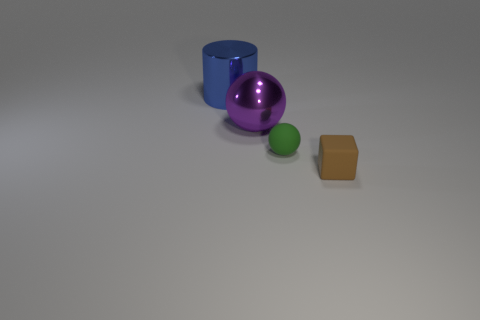What number of purple objects are small shiny spheres or large metal cylinders?
Offer a very short reply. 0. There is a object that is to the right of the purple ball and on the left side of the brown thing; how big is it?
Keep it short and to the point. Small. Are there more rubber cubes to the left of the tiny brown object than tiny rubber balls?
Your answer should be very brief. No. How many balls are either big yellow rubber objects or metallic things?
Offer a very short reply. 1. There is a object that is both left of the small brown matte object and on the right side of the big metal ball; what is its shape?
Make the answer very short. Sphere. Are there an equal number of tiny cubes that are in front of the large cylinder and metallic balls that are on the right side of the purple ball?
Your answer should be very brief. No. How many things are large metal cubes or matte cubes?
Offer a terse response. 1. What is the color of the metal object that is the same size as the metal cylinder?
Your answer should be compact. Purple. How many things are either large shiny things behind the metallic ball or objects that are to the right of the big blue shiny object?
Keep it short and to the point. 4. Is the number of purple spheres in front of the green sphere the same as the number of tiny brown blocks?
Offer a terse response. No. 